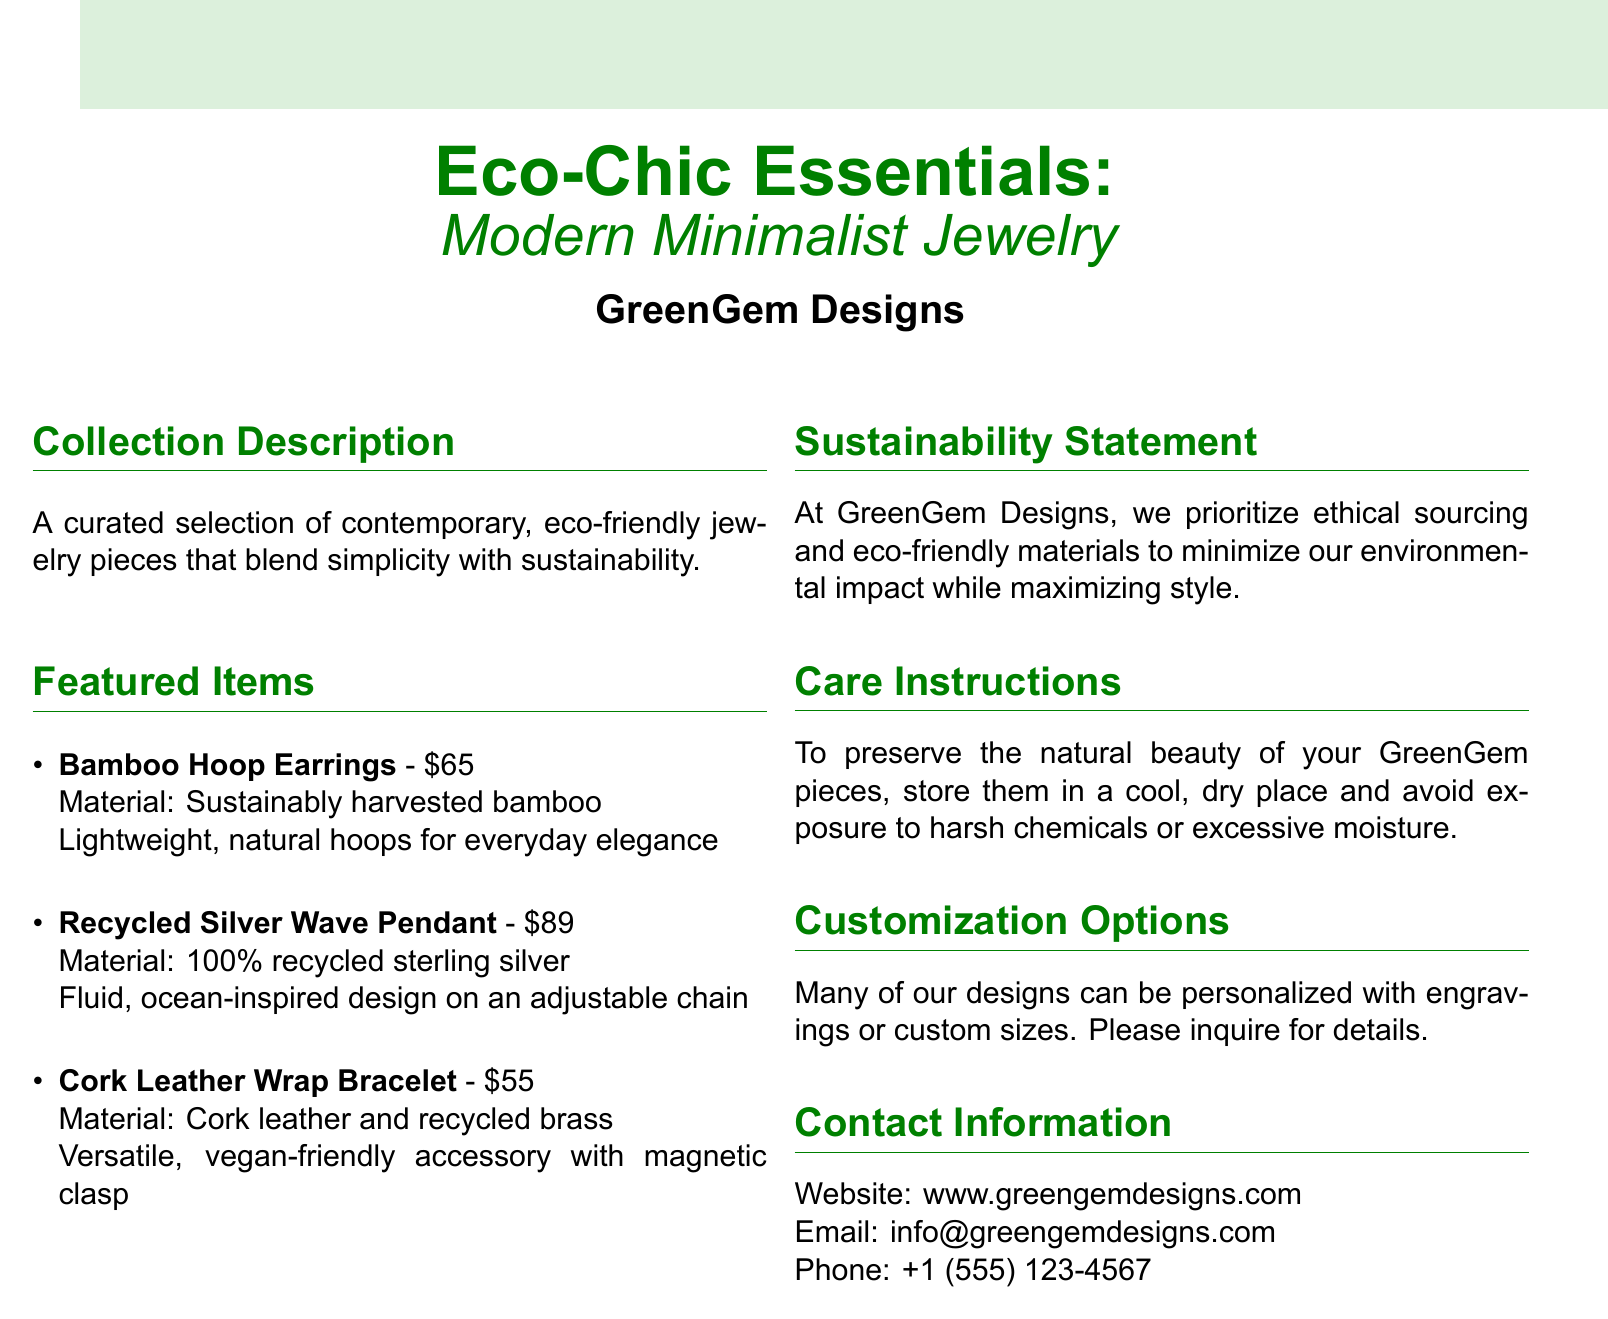what is the price of the Bamboo Hoop Earrings? The price is listed alongside the product description in the featured items section.
Answer: $65 what material is used in the Recycled Silver Wave Pendant? The material is explicitly stated in the item description.
Answer: 100% recycled sterling silver what is the price of the Cork Leather Wrap Bracelet? The price can be found next to the item's name in the featured items section.
Answer: $55 what is the focus of the sustainability statement? The statement highlights the company's commitment to ethical sourcing and eco-friendly materials.
Answer: Ethical sourcing and eco-friendly materials what type of material is Cork Leather? The material is defined in the product's description in the featured items section.
Answer: Cork leather how do you preserve the jewelry pieces? The care instructions outline specific actions to maintain the jewelry's condition.
Answer: Store in a cool, dry place what customization options are available? The customization section specifies available options for the jewelry designs.
Answer: Engravings or custom sizes what is the contact email for GreenGem Designs? The contact information section lists the email address for inquiries.
Answer: info@greengemdesigns.com how are the Bamboo Hoop Earrings described in terms of style? The description provides insight into the intended aesthetic or use of the item.
Answer: Everyday elegance 